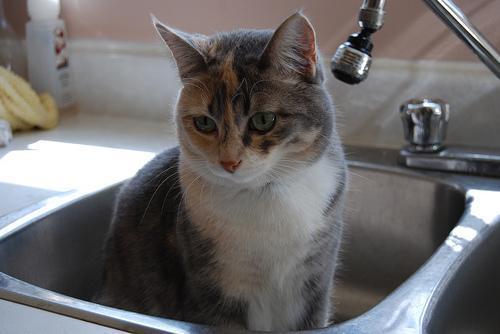How many cats are there?
Give a very brief answer. 1. How many cats are pictured?
Give a very brief answer. 1. 